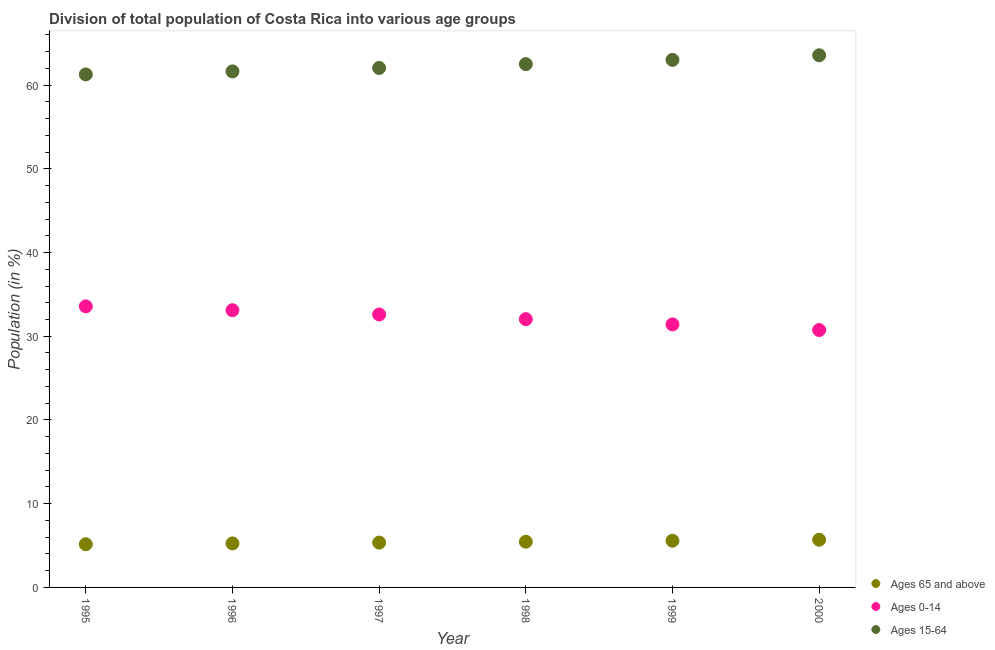How many different coloured dotlines are there?
Your response must be concise. 3. What is the percentage of population within the age-group of 65 and above in 1997?
Ensure brevity in your answer.  5.36. Across all years, what is the maximum percentage of population within the age-group of 65 and above?
Give a very brief answer. 5.7. Across all years, what is the minimum percentage of population within the age-group 15-64?
Provide a short and direct response. 61.27. In which year was the percentage of population within the age-group 0-14 minimum?
Give a very brief answer. 2000. What is the total percentage of population within the age-group of 65 and above in the graph?
Your response must be concise. 32.51. What is the difference between the percentage of population within the age-group 0-14 in 1995 and that in 2000?
Offer a very short reply. 2.82. What is the difference between the percentage of population within the age-group 0-14 in 2000 and the percentage of population within the age-group of 65 and above in 1995?
Provide a succinct answer. 25.58. What is the average percentage of population within the age-group 0-14 per year?
Offer a very short reply. 32.25. In the year 1995, what is the difference between the percentage of population within the age-group 0-14 and percentage of population within the age-group 15-64?
Provide a succinct answer. -27.7. What is the ratio of the percentage of population within the age-group 0-14 in 1996 to that in 1998?
Provide a succinct answer. 1.03. What is the difference between the highest and the second highest percentage of population within the age-group 0-14?
Your answer should be compact. 0.46. What is the difference between the highest and the lowest percentage of population within the age-group 0-14?
Ensure brevity in your answer.  2.82. Is the sum of the percentage of population within the age-group of 65 and above in 1995 and 2000 greater than the maximum percentage of population within the age-group 0-14 across all years?
Ensure brevity in your answer.  No. How many dotlines are there?
Give a very brief answer. 3. How many years are there in the graph?
Ensure brevity in your answer.  6. What is the difference between two consecutive major ticks on the Y-axis?
Give a very brief answer. 10. Does the graph contain any zero values?
Offer a terse response. No. Does the graph contain grids?
Ensure brevity in your answer.  No. How many legend labels are there?
Give a very brief answer. 3. How are the legend labels stacked?
Offer a terse response. Vertical. What is the title of the graph?
Keep it short and to the point. Division of total population of Costa Rica into various age groups
. Does "Renewable sources" appear as one of the legend labels in the graph?
Make the answer very short. No. What is the label or title of the X-axis?
Offer a very short reply. Year. What is the Population (in %) of Ages 65 and above in 1995?
Your response must be concise. 5.16. What is the Population (in %) in Ages 0-14 in 1995?
Offer a very short reply. 33.57. What is the Population (in %) of Ages 15-64 in 1995?
Your answer should be compact. 61.27. What is the Population (in %) of Ages 65 and above in 1996?
Your response must be concise. 5.26. What is the Population (in %) in Ages 0-14 in 1996?
Provide a succinct answer. 33.11. What is the Population (in %) of Ages 15-64 in 1996?
Ensure brevity in your answer.  61.63. What is the Population (in %) of Ages 65 and above in 1997?
Your response must be concise. 5.36. What is the Population (in %) in Ages 0-14 in 1997?
Offer a terse response. 32.6. What is the Population (in %) of Ages 15-64 in 1997?
Ensure brevity in your answer.  62.04. What is the Population (in %) of Ages 65 and above in 1998?
Make the answer very short. 5.46. What is the Population (in %) in Ages 0-14 in 1998?
Provide a succinct answer. 32.04. What is the Population (in %) of Ages 15-64 in 1998?
Your answer should be very brief. 62.5. What is the Population (in %) in Ages 65 and above in 1999?
Offer a terse response. 5.57. What is the Population (in %) in Ages 0-14 in 1999?
Your answer should be very brief. 31.42. What is the Population (in %) of Ages 15-64 in 1999?
Offer a very short reply. 63.01. What is the Population (in %) in Ages 65 and above in 2000?
Provide a short and direct response. 5.7. What is the Population (in %) in Ages 0-14 in 2000?
Make the answer very short. 30.74. What is the Population (in %) of Ages 15-64 in 2000?
Your answer should be very brief. 63.56. Across all years, what is the maximum Population (in %) of Ages 65 and above?
Offer a very short reply. 5.7. Across all years, what is the maximum Population (in %) in Ages 0-14?
Make the answer very short. 33.57. Across all years, what is the maximum Population (in %) of Ages 15-64?
Ensure brevity in your answer.  63.56. Across all years, what is the minimum Population (in %) of Ages 65 and above?
Your response must be concise. 5.16. Across all years, what is the minimum Population (in %) of Ages 0-14?
Your answer should be compact. 30.74. Across all years, what is the minimum Population (in %) in Ages 15-64?
Keep it short and to the point. 61.27. What is the total Population (in %) in Ages 65 and above in the graph?
Make the answer very short. 32.51. What is the total Population (in %) in Ages 0-14 in the graph?
Give a very brief answer. 193.48. What is the total Population (in %) of Ages 15-64 in the graph?
Give a very brief answer. 374.01. What is the difference between the Population (in %) in Ages 65 and above in 1995 and that in 1996?
Offer a very short reply. -0.1. What is the difference between the Population (in %) of Ages 0-14 in 1995 and that in 1996?
Offer a very short reply. 0.46. What is the difference between the Population (in %) in Ages 15-64 in 1995 and that in 1996?
Provide a succinct answer. -0.36. What is the difference between the Population (in %) of Ages 65 and above in 1995 and that in 1997?
Keep it short and to the point. -0.19. What is the difference between the Population (in %) of Ages 0-14 in 1995 and that in 1997?
Your answer should be very brief. 0.97. What is the difference between the Population (in %) of Ages 15-64 in 1995 and that in 1997?
Offer a very short reply. -0.77. What is the difference between the Population (in %) of Ages 65 and above in 1995 and that in 1998?
Offer a terse response. -0.3. What is the difference between the Population (in %) in Ages 0-14 in 1995 and that in 1998?
Make the answer very short. 1.53. What is the difference between the Population (in %) in Ages 15-64 in 1995 and that in 1998?
Give a very brief answer. -1.23. What is the difference between the Population (in %) in Ages 65 and above in 1995 and that in 1999?
Provide a short and direct response. -0.41. What is the difference between the Population (in %) in Ages 0-14 in 1995 and that in 1999?
Offer a terse response. 2.15. What is the difference between the Population (in %) of Ages 15-64 in 1995 and that in 1999?
Offer a terse response. -1.74. What is the difference between the Population (in %) of Ages 65 and above in 1995 and that in 2000?
Offer a terse response. -0.54. What is the difference between the Population (in %) in Ages 0-14 in 1995 and that in 2000?
Provide a short and direct response. 2.82. What is the difference between the Population (in %) in Ages 15-64 in 1995 and that in 2000?
Provide a succinct answer. -2.29. What is the difference between the Population (in %) of Ages 65 and above in 1996 and that in 1997?
Offer a terse response. -0.1. What is the difference between the Population (in %) of Ages 0-14 in 1996 and that in 1997?
Give a very brief answer. 0.51. What is the difference between the Population (in %) of Ages 15-64 in 1996 and that in 1997?
Your answer should be very brief. -0.41. What is the difference between the Population (in %) of Ages 65 and above in 1996 and that in 1998?
Your answer should be compact. -0.2. What is the difference between the Population (in %) of Ages 0-14 in 1996 and that in 1998?
Offer a terse response. 1.07. What is the difference between the Population (in %) in Ages 15-64 in 1996 and that in 1998?
Give a very brief answer. -0.87. What is the difference between the Population (in %) in Ages 65 and above in 1996 and that in 1999?
Keep it short and to the point. -0.32. What is the difference between the Population (in %) of Ages 0-14 in 1996 and that in 1999?
Ensure brevity in your answer.  1.69. What is the difference between the Population (in %) in Ages 15-64 in 1996 and that in 1999?
Provide a succinct answer. -1.37. What is the difference between the Population (in %) of Ages 65 and above in 1996 and that in 2000?
Your answer should be compact. -0.44. What is the difference between the Population (in %) of Ages 0-14 in 1996 and that in 2000?
Your response must be concise. 2.37. What is the difference between the Population (in %) of Ages 15-64 in 1996 and that in 2000?
Make the answer very short. -1.93. What is the difference between the Population (in %) of Ages 65 and above in 1997 and that in 1998?
Provide a succinct answer. -0.1. What is the difference between the Population (in %) in Ages 0-14 in 1997 and that in 1998?
Your answer should be very brief. 0.56. What is the difference between the Population (in %) in Ages 15-64 in 1997 and that in 1998?
Provide a short and direct response. -0.46. What is the difference between the Population (in %) of Ages 65 and above in 1997 and that in 1999?
Your answer should be compact. -0.22. What is the difference between the Population (in %) of Ages 0-14 in 1997 and that in 1999?
Provide a short and direct response. 1.18. What is the difference between the Population (in %) of Ages 15-64 in 1997 and that in 1999?
Keep it short and to the point. -0.96. What is the difference between the Population (in %) of Ages 65 and above in 1997 and that in 2000?
Give a very brief answer. -0.34. What is the difference between the Population (in %) in Ages 0-14 in 1997 and that in 2000?
Give a very brief answer. 1.86. What is the difference between the Population (in %) of Ages 15-64 in 1997 and that in 2000?
Give a very brief answer. -1.52. What is the difference between the Population (in %) in Ages 65 and above in 1998 and that in 1999?
Offer a very short reply. -0.11. What is the difference between the Population (in %) in Ages 0-14 in 1998 and that in 1999?
Your answer should be very brief. 0.62. What is the difference between the Population (in %) in Ages 15-64 in 1998 and that in 1999?
Provide a succinct answer. -0.51. What is the difference between the Population (in %) of Ages 65 and above in 1998 and that in 2000?
Keep it short and to the point. -0.24. What is the difference between the Population (in %) in Ages 0-14 in 1998 and that in 2000?
Your answer should be very brief. 1.3. What is the difference between the Population (in %) in Ages 15-64 in 1998 and that in 2000?
Offer a terse response. -1.06. What is the difference between the Population (in %) in Ages 65 and above in 1999 and that in 2000?
Your response must be concise. -0.12. What is the difference between the Population (in %) in Ages 0-14 in 1999 and that in 2000?
Offer a terse response. 0.68. What is the difference between the Population (in %) in Ages 15-64 in 1999 and that in 2000?
Provide a short and direct response. -0.55. What is the difference between the Population (in %) in Ages 65 and above in 1995 and the Population (in %) in Ages 0-14 in 1996?
Make the answer very short. -27.95. What is the difference between the Population (in %) of Ages 65 and above in 1995 and the Population (in %) of Ages 15-64 in 1996?
Offer a very short reply. -56.47. What is the difference between the Population (in %) in Ages 0-14 in 1995 and the Population (in %) in Ages 15-64 in 1996?
Make the answer very short. -28.07. What is the difference between the Population (in %) in Ages 65 and above in 1995 and the Population (in %) in Ages 0-14 in 1997?
Keep it short and to the point. -27.44. What is the difference between the Population (in %) of Ages 65 and above in 1995 and the Population (in %) of Ages 15-64 in 1997?
Keep it short and to the point. -56.88. What is the difference between the Population (in %) in Ages 0-14 in 1995 and the Population (in %) in Ages 15-64 in 1997?
Your response must be concise. -28.48. What is the difference between the Population (in %) in Ages 65 and above in 1995 and the Population (in %) in Ages 0-14 in 1998?
Provide a succinct answer. -26.88. What is the difference between the Population (in %) of Ages 65 and above in 1995 and the Population (in %) of Ages 15-64 in 1998?
Offer a terse response. -57.34. What is the difference between the Population (in %) in Ages 0-14 in 1995 and the Population (in %) in Ages 15-64 in 1998?
Make the answer very short. -28.93. What is the difference between the Population (in %) in Ages 65 and above in 1995 and the Population (in %) in Ages 0-14 in 1999?
Give a very brief answer. -26.26. What is the difference between the Population (in %) of Ages 65 and above in 1995 and the Population (in %) of Ages 15-64 in 1999?
Provide a short and direct response. -57.85. What is the difference between the Population (in %) of Ages 0-14 in 1995 and the Population (in %) of Ages 15-64 in 1999?
Give a very brief answer. -29.44. What is the difference between the Population (in %) in Ages 65 and above in 1995 and the Population (in %) in Ages 0-14 in 2000?
Offer a very short reply. -25.58. What is the difference between the Population (in %) of Ages 65 and above in 1995 and the Population (in %) of Ages 15-64 in 2000?
Keep it short and to the point. -58.4. What is the difference between the Population (in %) of Ages 0-14 in 1995 and the Population (in %) of Ages 15-64 in 2000?
Offer a terse response. -29.99. What is the difference between the Population (in %) in Ages 65 and above in 1996 and the Population (in %) in Ages 0-14 in 1997?
Provide a short and direct response. -27.34. What is the difference between the Population (in %) in Ages 65 and above in 1996 and the Population (in %) in Ages 15-64 in 1997?
Give a very brief answer. -56.79. What is the difference between the Population (in %) in Ages 0-14 in 1996 and the Population (in %) in Ages 15-64 in 1997?
Offer a terse response. -28.93. What is the difference between the Population (in %) in Ages 65 and above in 1996 and the Population (in %) in Ages 0-14 in 1998?
Make the answer very short. -26.78. What is the difference between the Population (in %) in Ages 65 and above in 1996 and the Population (in %) in Ages 15-64 in 1998?
Offer a terse response. -57.24. What is the difference between the Population (in %) in Ages 0-14 in 1996 and the Population (in %) in Ages 15-64 in 1998?
Keep it short and to the point. -29.39. What is the difference between the Population (in %) of Ages 65 and above in 1996 and the Population (in %) of Ages 0-14 in 1999?
Make the answer very short. -26.16. What is the difference between the Population (in %) in Ages 65 and above in 1996 and the Population (in %) in Ages 15-64 in 1999?
Offer a terse response. -57.75. What is the difference between the Population (in %) in Ages 0-14 in 1996 and the Population (in %) in Ages 15-64 in 1999?
Your response must be concise. -29.9. What is the difference between the Population (in %) of Ages 65 and above in 1996 and the Population (in %) of Ages 0-14 in 2000?
Give a very brief answer. -25.49. What is the difference between the Population (in %) in Ages 65 and above in 1996 and the Population (in %) in Ages 15-64 in 2000?
Keep it short and to the point. -58.3. What is the difference between the Population (in %) of Ages 0-14 in 1996 and the Population (in %) of Ages 15-64 in 2000?
Your answer should be compact. -30.45. What is the difference between the Population (in %) in Ages 65 and above in 1997 and the Population (in %) in Ages 0-14 in 1998?
Your answer should be compact. -26.68. What is the difference between the Population (in %) of Ages 65 and above in 1997 and the Population (in %) of Ages 15-64 in 1998?
Offer a terse response. -57.14. What is the difference between the Population (in %) of Ages 0-14 in 1997 and the Population (in %) of Ages 15-64 in 1998?
Offer a very short reply. -29.9. What is the difference between the Population (in %) of Ages 65 and above in 1997 and the Population (in %) of Ages 0-14 in 1999?
Keep it short and to the point. -26.06. What is the difference between the Population (in %) of Ages 65 and above in 1997 and the Population (in %) of Ages 15-64 in 1999?
Provide a succinct answer. -57.65. What is the difference between the Population (in %) of Ages 0-14 in 1997 and the Population (in %) of Ages 15-64 in 1999?
Offer a terse response. -30.41. What is the difference between the Population (in %) of Ages 65 and above in 1997 and the Population (in %) of Ages 0-14 in 2000?
Your response must be concise. -25.39. What is the difference between the Population (in %) of Ages 65 and above in 1997 and the Population (in %) of Ages 15-64 in 2000?
Give a very brief answer. -58.2. What is the difference between the Population (in %) in Ages 0-14 in 1997 and the Population (in %) in Ages 15-64 in 2000?
Keep it short and to the point. -30.96. What is the difference between the Population (in %) of Ages 65 and above in 1998 and the Population (in %) of Ages 0-14 in 1999?
Offer a very short reply. -25.96. What is the difference between the Population (in %) of Ages 65 and above in 1998 and the Population (in %) of Ages 15-64 in 1999?
Keep it short and to the point. -57.55. What is the difference between the Population (in %) of Ages 0-14 in 1998 and the Population (in %) of Ages 15-64 in 1999?
Provide a short and direct response. -30.97. What is the difference between the Population (in %) in Ages 65 and above in 1998 and the Population (in %) in Ages 0-14 in 2000?
Your answer should be compact. -25.28. What is the difference between the Population (in %) in Ages 65 and above in 1998 and the Population (in %) in Ages 15-64 in 2000?
Make the answer very short. -58.1. What is the difference between the Population (in %) in Ages 0-14 in 1998 and the Population (in %) in Ages 15-64 in 2000?
Your answer should be very brief. -31.52. What is the difference between the Population (in %) of Ages 65 and above in 1999 and the Population (in %) of Ages 0-14 in 2000?
Give a very brief answer. -25.17. What is the difference between the Population (in %) in Ages 65 and above in 1999 and the Population (in %) in Ages 15-64 in 2000?
Provide a short and direct response. -57.99. What is the difference between the Population (in %) in Ages 0-14 in 1999 and the Population (in %) in Ages 15-64 in 2000?
Give a very brief answer. -32.14. What is the average Population (in %) of Ages 65 and above per year?
Give a very brief answer. 5.42. What is the average Population (in %) in Ages 0-14 per year?
Make the answer very short. 32.25. What is the average Population (in %) in Ages 15-64 per year?
Give a very brief answer. 62.34. In the year 1995, what is the difference between the Population (in %) in Ages 65 and above and Population (in %) in Ages 0-14?
Provide a short and direct response. -28.41. In the year 1995, what is the difference between the Population (in %) in Ages 65 and above and Population (in %) in Ages 15-64?
Keep it short and to the point. -56.11. In the year 1995, what is the difference between the Population (in %) of Ages 0-14 and Population (in %) of Ages 15-64?
Your answer should be compact. -27.7. In the year 1996, what is the difference between the Population (in %) of Ages 65 and above and Population (in %) of Ages 0-14?
Offer a very short reply. -27.85. In the year 1996, what is the difference between the Population (in %) of Ages 65 and above and Population (in %) of Ages 15-64?
Provide a short and direct response. -56.38. In the year 1996, what is the difference between the Population (in %) in Ages 0-14 and Population (in %) in Ages 15-64?
Provide a short and direct response. -28.52. In the year 1997, what is the difference between the Population (in %) of Ages 65 and above and Population (in %) of Ages 0-14?
Make the answer very short. -27.24. In the year 1997, what is the difference between the Population (in %) of Ages 65 and above and Population (in %) of Ages 15-64?
Offer a very short reply. -56.69. In the year 1997, what is the difference between the Population (in %) of Ages 0-14 and Population (in %) of Ages 15-64?
Make the answer very short. -29.44. In the year 1998, what is the difference between the Population (in %) in Ages 65 and above and Population (in %) in Ages 0-14?
Offer a terse response. -26.58. In the year 1998, what is the difference between the Population (in %) in Ages 65 and above and Population (in %) in Ages 15-64?
Provide a succinct answer. -57.04. In the year 1998, what is the difference between the Population (in %) in Ages 0-14 and Population (in %) in Ages 15-64?
Ensure brevity in your answer.  -30.46. In the year 1999, what is the difference between the Population (in %) in Ages 65 and above and Population (in %) in Ages 0-14?
Your answer should be compact. -25.85. In the year 1999, what is the difference between the Population (in %) in Ages 65 and above and Population (in %) in Ages 15-64?
Give a very brief answer. -57.43. In the year 1999, what is the difference between the Population (in %) of Ages 0-14 and Population (in %) of Ages 15-64?
Give a very brief answer. -31.59. In the year 2000, what is the difference between the Population (in %) of Ages 65 and above and Population (in %) of Ages 0-14?
Provide a short and direct response. -25.05. In the year 2000, what is the difference between the Population (in %) of Ages 65 and above and Population (in %) of Ages 15-64?
Make the answer very short. -57.86. In the year 2000, what is the difference between the Population (in %) in Ages 0-14 and Population (in %) in Ages 15-64?
Make the answer very short. -32.82. What is the ratio of the Population (in %) of Ages 65 and above in 1995 to that in 1996?
Give a very brief answer. 0.98. What is the ratio of the Population (in %) of Ages 0-14 in 1995 to that in 1996?
Ensure brevity in your answer.  1.01. What is the ratio of the Population (in %) of Ages 15-64 in 1995 to that in 1996?
Give a very brief answer. 0.99. What is the ratio of the Population (in %) in Ages 65 and above in 1995 to that in 1997?
Give a very brief answer. 0.96. What is the ratio of the Population (in %) of Ages 0-14 in 1995 to that in 1997?
Offer a very short reply. 1.03. What is the ratio of the Population (in %) in Ages 15-64 in 1995 to that in 1997?
Offer a very short reply. 0.99. What is the ratio of the Population (in %) of Ages 65 and above in 1995 to that in 1998?
Offer a very short reply. 0.95. What is the ratio of the Population (in %) of Ages 0-14 in 1995 to that in 1998?
Give a very brief answer. 1.05. What is the ratio of the Population (in %) in Ages 15-64 in 1995 to that in 1998?
Provide a succinct answer. 0.98. What is the ratio of the Population (in %) of Ages 65 and above in 1995 to that in 1999?
Your answer should be very brief. 0.93. What is the ratio of the Population (in %) of Ages 0-14 in 1995 to that in 1999?
Your answer should be very brief. 1.07. What is the ratio of the Population (in %) in Ages 15-64 in 1995 to that in 1999?
Give a very brief answer. 0.97. What is the ratio of the Population (in %) in Ages 65 and above in 1995 to that in 2000?
Offer a terse response. 0.91. What is the ratio of the Population (in %) of Ages 0-14 in 1995 to that in 2000?
Offer a very short reply. 1.09. What is the ratio of the Population (in %) of Ages 65 and above in 1996 to that in 1997?
Offer a very short reply. 0.98. What is the ratio of the Population (in %) of Ages 0-14 in 1996 to that in 1997?
Offer a very short reply. 1.02. What is the ratio of the Population (in %) in Ages 15-64 in 1996 to that in 1997?
Your answer should be compact. 0.99. What is the ratio of the Population (in %) in Ages 65 and above in 1996 to that in 1998?
Your response must be concise. 0.96. What is the ratio of the Population (in %) in Ages 0-14 in 1996 to that in 1998?
Your answer should be very brief. 1.03. What is the ratio of the Population (in %) in Ages 15-64 in 1996 to that in 1998?
Make the answer very short. 0.99. What is the ratio of the Population (in %) in Ages 65 and above in 1996 to that in 1999?
Your response must be concise. 0.94. What is the ratio of the Population (in %) of Ages 0-14 in 1996 to that in 1999?
Ensure brevity in your answer.  1.05. What is the ratio of the Population (in %) of Ages 15-64 in 1996 to that in 1999?
Your answer should be very brief. 0.98. What is the ratio of the Population (in %) in Ages 65 and above in 1996 to that in 2000?
Offer a very short reply. 0.92. What is the ratio of the Population (in %) in Ages 0-14 in 1996 to that in 2000?
Your answer should be very brief. 1.08. What is the ratio of the Population (in %) in Ages 15-64 in 1996 to that in 2000?
Provide a succinct answer. 0.97. What is the ratio of the Population (in %) in Ages 65 and above in 1997 to that in 1998?
Your answer should be very brief. 0.98. What is the ratio of the Population (in %) in Ages 0-14 in 1997 to that in 1998?
Make the answer very short. 1.02. What is the ratio of the Population (in %) in Ages 15-64 in 1997 to that in 1998?
Keep it short and to the point. 0.99. What is the ratio of the Population (in %) in Ages 65 and above in 1997 to that in 1999?
Keep it short and to the point. 0.96. What is the ratio of the Population (in %) in Ages 0-14 in 1997 to that in 1999?
Make the answer very short. 1.04. What is the ratio of the Population (in %) in Ages 15-64 in 1997 to that in 1999?
Ensure brevity in your answer.  0.98. What is the ratio of the Population (in %) in Ages 65 and above in 1997 to that in 2000?
Offer a terse response. 0.94. What is the ratio of the Population (in %) in Ages 0-14 in 1997 to that in 2000?
Your response must be concise. 1.06. What is the ratio of the Population (in %) of Ages 15-64 in 1997 to that in 2000?
Provide a succinct answer. 0.98. What is the ratio of the Population (in %) of Ages 65 and above in 1998 to that in 1999?
Provide a succinct answer. 0.98. What is the ratio of the Population (in %) in Ages 0-14 in 1998 to that in 1999?
Your answer should be very brief. 1.02. What is the ratio of the Population (in %) of Ages 15-64 in 1998 to that in 1999?
Your answer should be very brief. 0.99. What is the ratio of the Population (in %) in Ages 65 and above in 1998 to that in 2000?
Provide a succinct answer. 0.96. What is the ratio of the Population (in %) of Ages 0-14 in 1998 to that in 2000?
Your response must be concise. 1.04. What is the ratio of the Population (in %) in Ages 15-64 in 1998 to that in 2000?
Your answer should be very brief. 0.98. What is the ratio of the Population (in %) in Ages 65 and above in 1999 to that in 2000?
Provide a short and direct response. 0.98. What is the ratio of the Population (in %) of Ages 15-64 in 1999 to that in 2000?
Give a very brief answer. 0.99. What is the difference between the highest and the second highest Population (in %) of Ages 65 and above?
Your response must be concise. 0.12. What is the difference between the highest and the second highest Population (in %) in Ages 0-14?
Your response must be concise. 0.46. What is the difference between the highest and the second highest Population (in %) in Ages 15-64?
Provide a succinct answer. 0.55. What is the difference between the highest and the lowest Population (in %) of Ages 65 and above?
Give a very brief answer. 0.54. What is the difference between the highest and the lowest Population (in %) of Ages 0-14?
Make the answer very short. 2.82. What is the difference between the highest and the lowest Population (in %) in Ages 15-64?
Provide a short and direct response. 2.29. 